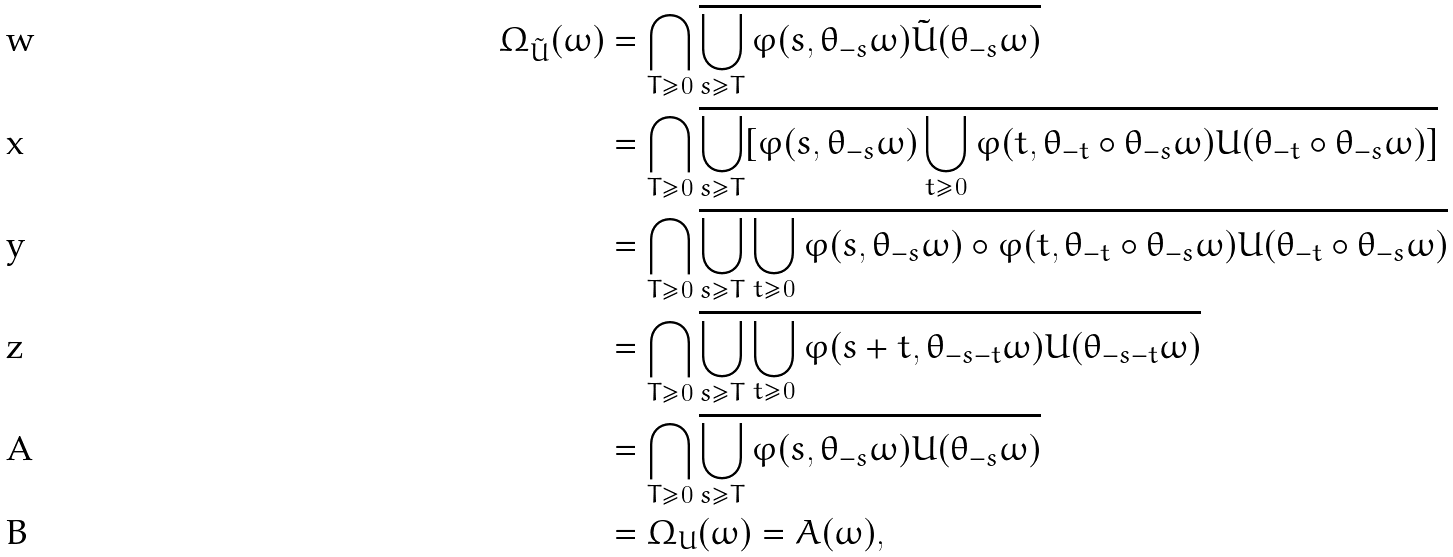<formula> <loc_0><loc_0><loc_500><loc_500>\Omega _ { \tilde { U } } ( \omega ) & = \bigcap _ { T \geq 0 } \overline { \bigcup _ { s \geq T } \varphi ( s , \theta _ { - s } \omega ) \tilde { U } ( \theta _ { - s } \omega ) } \\ & = \bigcap _ { T \geq 0 } \overline { \bigcup _ { s \geq T } [ \varphi ( s , \theta _ { - s } \omega ) \bigcup _ { t \geq 0 } \varphi ( t , \theta _ { - t } \circ \theta _ { - s } \omega ) U ( \theta _ { - t } \circ \theta _ { - s } \omega ) ] } \\ & = \bigcap _ { T \geq 0 } \overline { \bigcup _ { s \geq T } \bigcup _ { t \geq 0 } \varphi ( s , \theta _ { - s } \omega ) \circ \varphi ( t , \theta _ { - t } \circ \theta _ { - s } \omega ) U ( \theta _ { - t } \circ \theta _ { - s } \omega ) } \\ & = \bigcap _ { T \geq 0 } \overline { \bigcup _ { s \geq T } \bigcup _ { t \geq 0 } \varphi ( s + t , \theta _ { - s - t } \omega ) U ( \theta _ { - s - t } \omega ) } \\ & = \bigcap _ { T \geq 0 } \overline { \bigcup _ { s \geq T } \varphi ( s , \theta _ { - s } \omega ) U ( \theta _ { - s } \omega ) } \\ & = \Omega _ { U } ( \omega ) = A ( \omega ) ,</formula> 